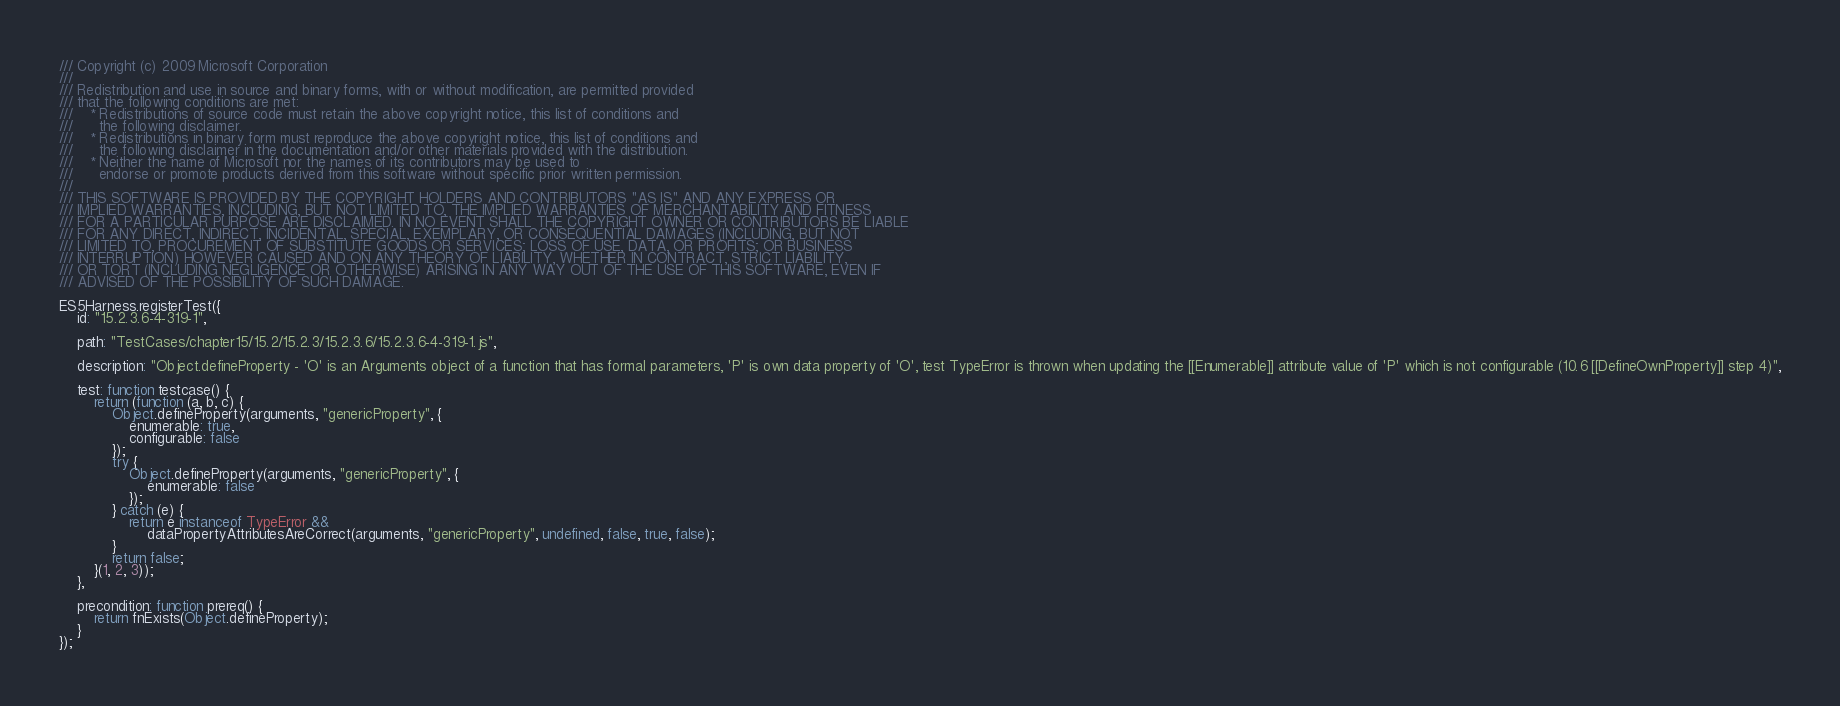<code> <loc_0><loc_0><loc_500><loc_500><_JavaScript_>/// Copyright (c) 2009 Microsoft Corporation 
/// 
/// Redistribution and use in source and binary forms, with or without modification, are permitted provided
/// that the following conditions are met: 
///    * Redistributions of source code must retain the above copyright notice, this list of conditions and
///      the following disclaimer. 
///    * Redistributions in binary form must reproduce the above copyright notice, this list of conditions and 
///      the following disclaimer in the documentation and/or other materials provided with the distribution.  
///    * Neither the name of Microsoft nor the names of its contributors may be used to
///      endorse or promote products derived from this software without specific prior written permission.
/// 
/// THIS SOFTWARE IS PROVIDED BY THE COPYRIGHT HOLDERS AND CONTRIBUTORS "AS IS" AND ANY EXPRESS OR
/// IMPLIED WARRANTIES, INCLUDING, BUT NOT LIMITED TO, THE IMPLIED WARRANTIES OF MERCHANTABILITY AND FITNESS
/// FOR A PARTICULAR PURPOSE ARE DISCLAIMED. IN NO EVENT SHALL THE COPYRIGHT OWNER OR CONTRIBUTORS BE LIABLE
/// FOR ANY DIRECT, INDIRECT, INCIDENTAL, SPECIAL, EXEMPLARY, OR CONSEQUENTIAL DAMAGES (INCLUDING, BUT NOT
/// LIMITED TO, PROCUREMENT OF SUBSTITUTE GOODS OR SERVICES; LOSS OF USE, DATA, OR PROFITS; OR BUSINESS
/// INTERRUPTION) HOWEVER CAUSED AND ON ANY THEORY OF LIABILITY, WHETHER IN CONTRACT, STRICT LIABILITY,
/// OR TORT (INCLUDING NEGLIGENCE OR OTHERWISE) ARISING IN ANY WAY OUT OF THE USE OF THIS SOFTWARE, EVEN IF
/// ADVISED OF THE POSSIBILITY OF SUCH DAMAGE.

ES5Harness.registerTest({
    id: "15.2.3.6-4-319-1",

    path: "TestCases/chapter15/15.2/15.2.3/15.2.3.6/15.2.3.6-4-319-1.js",

    description: "Object.defineProperty - 'O' is an Arguments object of a function that has formal parameters, 'P' is own data property of 'O', test TypeError is thrown when updating the [[Enumerable]] attribute value of 'P' which is not configurable (10.6 [[DefineOwnProperty]] step 4)",

    test: function testcase() {
        return (function (a, b, c) {
            Object.defineProperty(arguments, "genericProperty", {
                enumerable: true,
                configurable: false
            });
            try {
                Object.defineProperty(arguments, "genericProperty", {
                    enumerable: false
                });
            } catch (e) {
                return e instanceof TypeError &&
                    dataPropertyAttributesAreCorrect(arguments, "genericProperty", undefined, false, true, false);
            }
            return false;
        }(1, 2, 3));
    },

    precondition: function prereq() {
        return fnExists(Object.defineProperty);
    }
});
</code> 